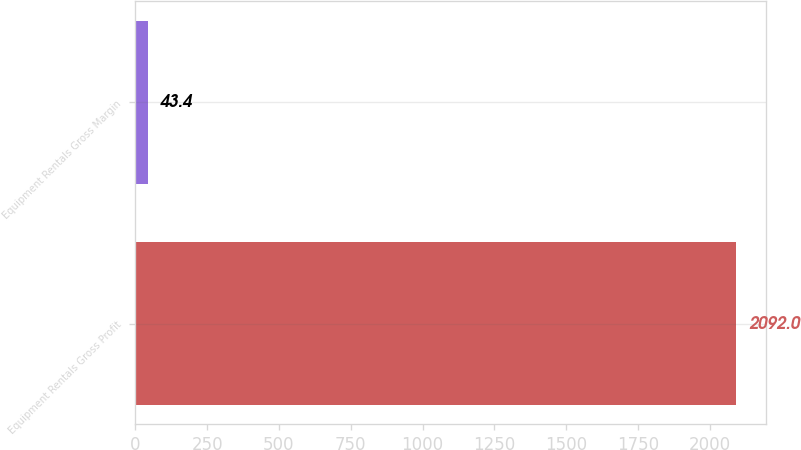Convert chart to OTSL. <chart><loc_0><loc_0><loc_500><loc_500><bar_chart><fcel>Equipment Rentals Gross Profit<fcel>Equipment Rentals Gross Margin<nl><fcel>2092<fcel>43.4<nl></chart> 